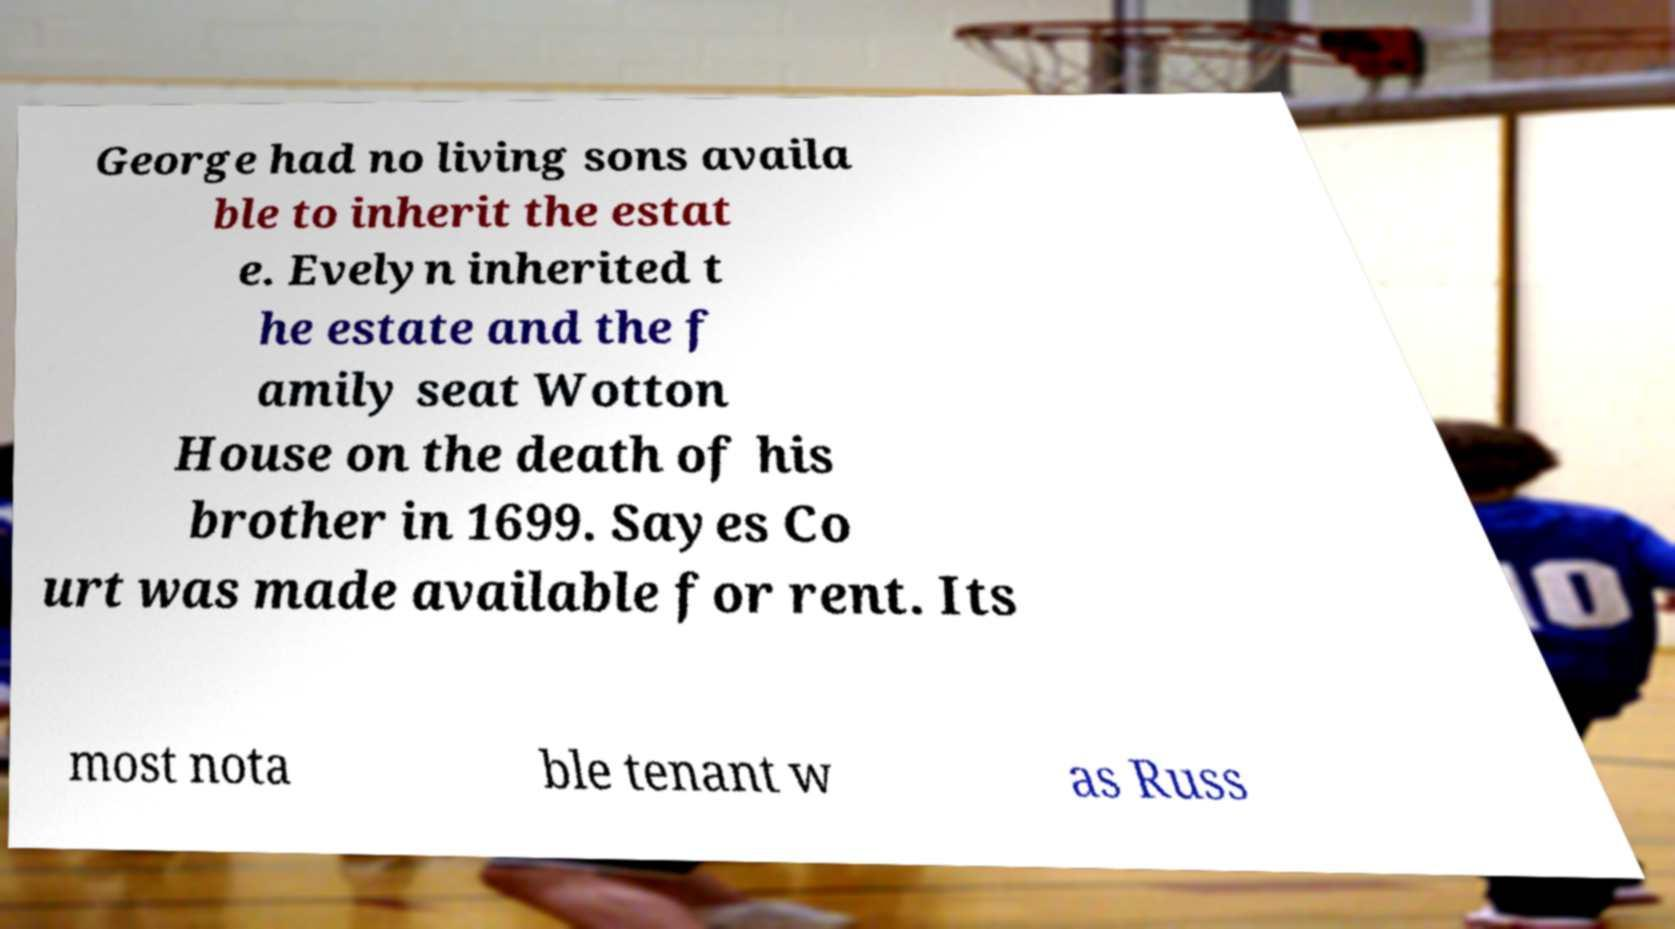For documentation purposes, I need the text within this image transcribed. Could you provide that? George had no living sons availa ble to inherit the estat e. Evelyn inherited t he estate and the f amily seat Wotton House on the death of his brother in 1699. Sayes Co urt was made available for rent. Its most nota ble tenant w as Russ 